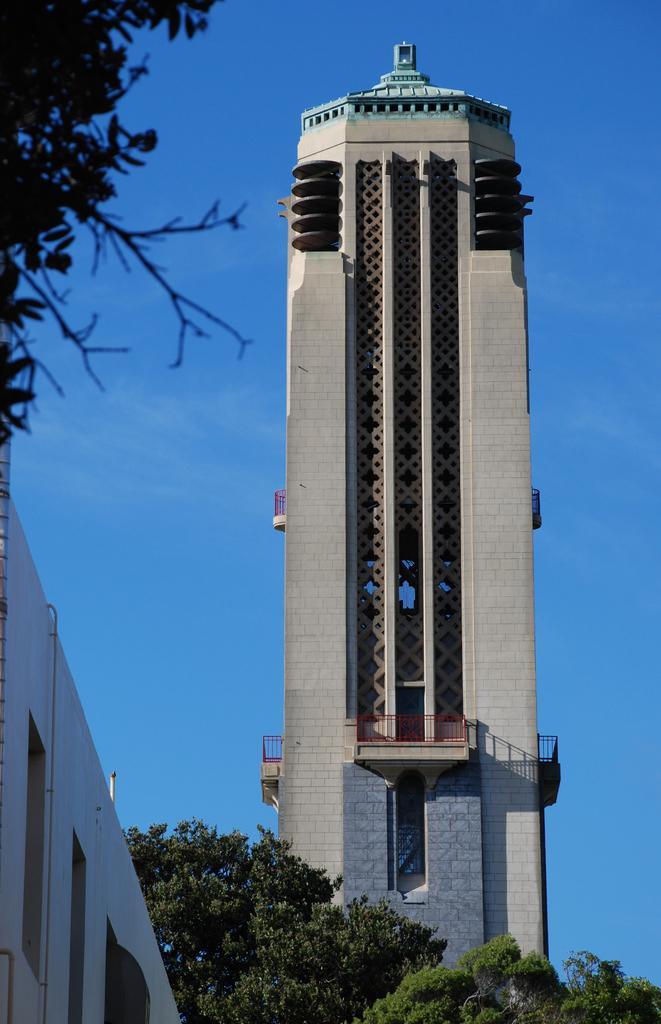Describe this image in one or two sentences. In this image, this looks like a building tower. These are the trees. On the right side of the image, I think this is a wall. Here is the sky. 